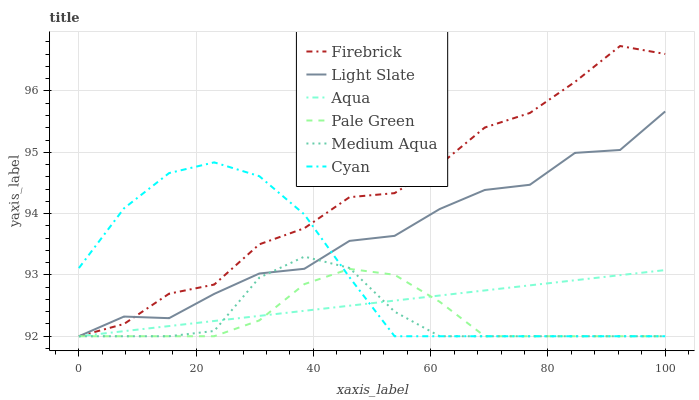Does Pale Green have the minimum area under the curve?
Answer yes or no. Yes. Does Firebrick have the maximum area under the curve?
Answer yes or no. Yes. Does Aqua have the minimum area under the curve?
Answer yes or no. No. Does Aqua have the maximum area under the curve?
Answer yes or no. No. Is Aqua the smoothest?
Answer yes or no. Yes. Is Firebrick the roughest?
Answer yes or no. Yes. Is Firebrick the smoothest?
Answer yes or no. No. Is Aqua the roughest?
Answer yes or no. No. Does Light Slate have the lowest value?
Answer yes or no. Yes. Does Firebrick have the highest value?
Answer yes or no. Yes. Does Aqua have the highest value?
Answer yes or no. No. Does Cyan intersect Firebrick?
Answer yes or no. Yes. Is Cyan less than Firebrick?
Answer yes or no. No. Is Cyan greater than Firebrick?
Answer yes or no. No. 